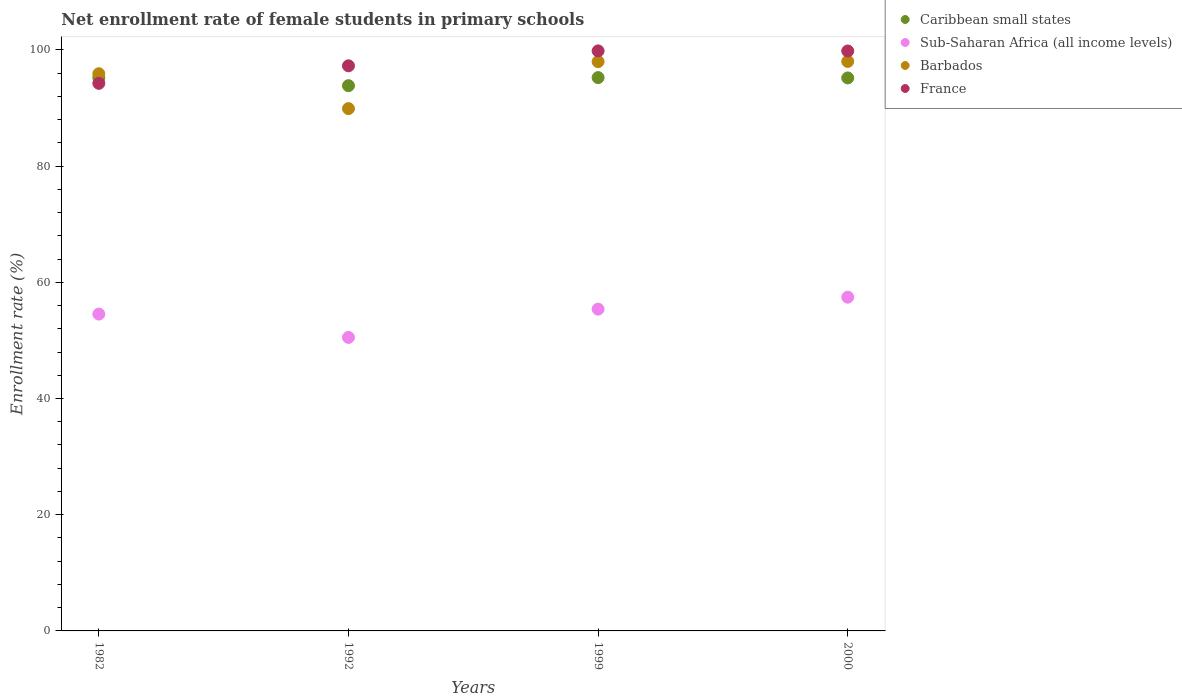How many different coloured dotlines are there?
Offer a terse response. 4. Is the number of dotlines equal to the number of legend labels?
Your answer should be compact. Yes. What is the net enrollment rate of female students in primary schools in Caribbean small states in 1992?
Make the answer very short. 93.84. Across all years, what is the maximum net enrollment rate of female students in primary schools in Sub-Saharan Africa (all income levels)?
Keep it short and to the point. 57.44. Across all years, what is the minimum net enrollment rate of female students in primary schools in Barbados?
Keep it short and to the point. 89.89. What is the total net enrollment rate of female students in primary schools in Sub-Saharan Africa (all income levels) in the graph?
Keep it short and to the point. 217.87. What is the difference between the net enrollment rate of female students in primary schools in Barbados in 1982 and that in 1999?
Offer a very short reply. -2.08. What is the difference between the net enrollment rate of female students in primary schools in Caribbean small states in 2000 and the net enrollment rate of female students in primary schools in Sub-Saharan Africa (all income levels) in 1982?
Provide a short and direct response. 40.64. What is the average net enrollment rate of female students in primary schools in Barbados per year?
Provide a short and direct response. 95.44. In the year 1992, what is the difference between the net enrollment rate of female students in primary schools in France and net enrollment rate of female students in primary schools in Sub-Saharan Africa (all income levels)?
Your answer should be compact. 46.74. In how many years, is the net enrollment rate of female students in primary schools in Caribbean small states greater than 96 %?
Give a very brief answer. 0. What is the ratio of the net enrollment rate of female students in primary schools in Sub-Saharan Africa (all income levels) in 1982 to that in 2000?
Your answer should be compact. 0.95. Is the net enrollment rate of female students in primary schools in Sub-Saharan Africa (all income levels) in 1999 less than that in 2000?
Ensure brevity in your answer.  Yes. What is the difference between the highest and the second highest net enrollment rate of female students in primary schools in Caribbean small states?
Offer a very short reply. 0. What is the difference between the highest and the lowest net enrollment rate of female students in primary schools in Barbados?
Your response must be concise. 8.12. In how many years, is the net enrollment rate of female students in primary schools in France greater than the average net enrollment rate of female students in primary schools in France taken over all years?
Your answer should be very brief. 2. Is the sum of the net enrollment rate of female students in primary schools in Barbados in 1992 and 1999 greater than the maximum net enrollment rate of female students in primary schools in Sub-Saharan Africa (all income levels) across all years?
Keep it short and to the point. Yes. Is it the case that in every year, the sum of the net enrollment rate of female students in primary schools in Barbados and net enrollment rate of female students in primary schools in France  is greater than the sum of net enrollment rate of female students in primary schools in Caribbean small states and net enrollment rate of female students in primary schools in Sub-Saharan Africa (all income levels)?
Your answer should be very brief. Yes. Is it the case that in every year, the sum of the net enrollment rate of female students in primary schools in Sub-Saharan Africa (all income levels) and net enrollment rate of female students in primary schools in Caribbean small states  is greater than the net enrollment rate of female students in primary schools in France?
Provide a short and direct response. Yes. Is the net enrollment rate of female students in primary schools in Caribbean small states strictly less than the net enrollment rate of female students in primary schools in Barbados over the years?
Provide a succinct answer. No. What is the difference between two consecutive major ticks on the Y-axis?
Provide a succinct answer. 20. Does the graph contain grids?
Your answer should be compact. No. How are the legend labels stacked?
Offer a terse response. Vertical. What is the title of the graph?
Give a very brief answer. Net enrollment rate of female students in primary schools. What is the label or title of the Y-axis?
Keep it short and to the point. Enrollment rate (%). What is the Enrollment rate (%) of Caribbean small states in 1982?
Your answer should be very brief. 95.23. What is the Enrollment rate (%) in Sub-Saharan Africa (all income levels) in 1982?
Your answer should be compact. 54.53. What is the Enrollment rate (%) of Barbados in 1982?
Make the answer very short. 95.89. What is the Enrollment rate (%) in France in 1982?
Ensure brevity in your answer.  94.24. What is the Enrollment rate (%) in Caribbean small states in 1992?
Ensure brevity in your answer.  93.84. What is the Enrollment rate (%) of Sub-Saharan Africa (all income levels) in 1992?
Provide a succinct answer. 50.52. What is the Enrollment rate (%) in Barbados in 1992?
Ensure brevity in your answer.  89.89. What is the Enrollment rate (%) in France in 1992?
Provide a short and direct response. 97.26. What is the Enrollment rate (%) of Caribbean small states in 1999?
Offer a very short reply. 95.23. What is the Enrollment rate (%) of Sub-Saharan Africa (all income levels) in 1999?
Your response must be concise. 55.38. What is the Enrollment rate (%) in Barbados in 1999?
Keep it short and to the point. 97.98. What is the Enrollment rate (%) in France in 1999?
Your answer should be very brief. 99.82. What is the Enrollment rate (%) of Caribbean small states in 2000?
Provide a succinct answer. 95.17. What is the Enrollment rate (%) of Sub-Saharan Africa (all income levels) in 2000?
Give a very brief answer. 57.44. What is the Enrollment rate (%) in Barbados in 2000?
Your answer should be very brief. 98.01. What is the Enrollment rate (%) of France in 2000?
Provide a succinct answer. 99.81. Across all years, what is the maximum Enrollment rate (%) in Caribbean small states?
Keep it short and to the point. 95.23. Across all years, what is the maximum Enrollment rate (%) in Sub-Saharan Africa (all income levels)?
Your answer should be compact. 57.44. Across all years, what is the maximum Enrollment rate (%) of Barbados?
Ensure brevity in your answer.  98.01. Across all years, what is the maximum Enrollment rate (%) of France?
Offer a terse response. 99.82. Across all years, what is the minimum Enrollment rate (%) in Caribbean small states?
Provide a short and direct response. 93.84. Across all years, what is the minimum Enrollment rate (%) in Sub-Saharan Africa (all income levels)?
Keep it short and to the point. 50.52. Across all years, what is the minimum Enrollment rate (%) in Barbados?
Make the answer very short. 89.89. Across all years, what is the minimum Enrollment rate (%) of France?
Make the answer very short. 94.24. What is the total Enrollment rate (%) in Caribbean small states in the graph?
Offer a terse response. 379.46. What is the total Enrollment rate (%) in Sub-Saharan Africa (all income levels) in the graph?
Provide a short and direct response. 217.87. What is the total Enrollment rate (%) of Barbados in the graph?
Your answer should be compact. 381.77. What is the total Enrollment rate (%) in France in the graph?
Offer a very short reply. 391.12. What is the difference between the Enrollment rate (%) in Caribbean small states in 1982 and that in 1992?
Your answer should be very brief. 1.39. What is the difference between the Enrollment rate (%) of Sub-Saharan Africa (all income levels) in 1982 and that in 1992?
Ensure brevity in your answer.  4.01. What is the difference between the Enrollment rate (%) in Barbados in 1982 and that in 1992?
Your response must be concise. 6. What is the difference between the Enrollment rate (%) in France in 1982 and that in 1992?
Your answer should be very brief. -3.02. What is the difference between the Enrollment rate (%) of Caribbean small states in 1982 and that in 1999?
Provide a succinct answer. -0. What is the difference between the Enrollment rate (%) in Sub-Saharan Africa (all income levels) in 1982 and that in 1999?
Give a very brief answer. -0.85. What is the difference between the Enrollment rate (%) in Barbados in 1982 and that in 1999?
Ensure brevity in your answer.  -2.08. What is the difference between the Enrollment rate (%) in France in 1982 and that in 1999?
Your answer should be compact. -5.58. What is the difference between the Enrollment rate (%) of Caribbean small states in 1982 and that in 2000?
Offer a very short reply. 0.05. What is the difference between the Enrollment rate (%) of Sub-Saharan Africa (all income levels) in 1982 and that in 2000?
Your response must be concise. -2.91. What is the difference between the Enrollment rate (%) of Barbados in 1982 and that in 2000?
Your answer should be compact. -2.12. What is the difference between the Enrollment rate (%) in France in 1982 and that in 2000?
Offer a very short reply. -5.57. What is the difference between the Enrollment rate (%) in Caribbean small states in 1992 and that in 1999?
Provide a short and direct response. -1.39. What is the difference between the Enrollment rate (%) in Sub-Saharan Africa (all income levels) in 1992 and that in 1999?
Make the answer very short. -4.86. What is the difference between the Enrollment rate (%) of Barbados in 1992 and that in 1999?
Provide a succinct answer. -8.09. What is the difference between the Enrollment rate (%) of France in 1992 and that in 1999?
Offer a very short reply. -2.57. What is the difference between the Enrollment rate (%) in Caribbean small states in 1992 and that in 2000?
Offer a very short reply. -1.34. What is the difference between the Enrollment rate (%) of Sub-Saharan Africa (all income levels) in 1992 and that in 2000?
Your response must be concise. -6.92. What is the difference between the Enrollment rate (%) of Barbados in 1992 and that in 2000?
Your answer should be very brief. -8.12. What is the difference between the Enrollment rate (%) of France in 1992 and that in 2000?
Your response must be concise. -2.55. What is the difference between the Enrollment rate (%) in Caribbean small states in 1999 and that in 2000?
Make the answer very short. 0.06. What is the difference between the Enrollment rate (%) of Sub-Saharan Africa (all income levels) in 1999 and that in 2000?
Your answer should be very brief. -2.06. What is the difference between the Enrollment rate (%) in Barbados in 1999 and that in 2000?
Your response must be concise. -0.03. What is the difference between the Enrollment rate (%) in France in 1999 and that in 2000?
Provide a succinct answer. 0.02. What is the difference between the Enrollment rate (%) in Caribbean small states in 1982 and the Enrollment rate (%) in Sub-Saharan Africa (all income levels) in 1992?
Give a very brief answer. 44.71. What is the difference between the Enrollment rate (%) in Caribbean small states in 1982 and the Enrollment rate (%) in Barbados in 1992?
Provide a succinct answer. 5.34. What is the difference between the Enrollment rate (%) in Caribbean small states in 1982 and the Enrollment rate (%) in France in 1992?
Keep it short and to the point. -2.03. What is the difference between the Enrollment rate (%) in Sub-Saharan Africa (all income levels) in 1982 and the Enrollment rate (%) in Barbados in 1992?
Offer a very short reply. -35.36. What is the difference between the Enrollment rate (%) in Sub-Saharan Africa (all income levels) in 1982 and the Enrollment rate (%) in France in 1992?
Ensure brevity in your answer.  -42.73. What is the difference between the Enrollment rate (%) of Barbados in 1982 and the Enrollment rate (%) of France in 1992?
Your answer should be compact. -1.36. What is the difference between the Enrollment rate (%) in Caribbean small states in 1982 and the Enrollment rate (%) in Sub-Saharan Africa (all income levels) in 1999?
Your answer should be compact. 39.85. What is the difference between the Enrollment rate (%) in Caribbean small states in 1982 and the Enrollment rate (%) in Barbados in 1999?
Give a very brief answer. -2.75. What is the difference between the Enrollment rate (%) in Caribbean small states in 1982 and the Enrollment rate (%) in France in 1999?
Give a very brief answer. -4.6. What is the difference between the Enrollment rate (%) in Sub-Saharan Africa (all income levels) in 1982 and the Enrollment rate (%) in Barbados in 1999?
Give a very brief answer. -43.45. What is the difference between the Enrollment rate (%) in Sub-Saharan Africa (all income levels) in 1982 and the Enrollment rate (%) in France in 1999?
Offer a terse response. -45.29. What is the difference between the Enrollment rate (%) of Barbados in 1982 and the Enrollment rate (%) of France in 1999?
Your response must be concise. -3.93. What is the difference between the Enrollment rate (%) in Caribbean small states in 1982 and the Enrollment rate (%) in Sub-Saharan Africa (all income levels) in 2000?
Provide a short and direct response. 37.79. What is the difference between the Enrollment rate (%) in Caribbean small states in 1982 and the Enrollment rate (%) in Barbados in 2000?
Give a very brief answer. -2.78. What is the difference between the Enrollment rate (%) in Caribbean small states in 1982 and the Enrollment rate (%) in France in 2000?
Your answer should be compact. -4.58. What is the difference between the Enrollment rate (%) of Sub-Saharan Africa (all income levels) in 1982 and the Enrollment rate (%) of Barbados in 2000?
Provide a short and direct response. -43.48. What is the difference between the Enrollment rate (%) in Sub-Saharan Africa (all income levels) in 1982 and the Enrollment rate (%) in France in 2000?
Ensure brevity in your answer.  -45.28. What is the difference between the Enrollment rate (%) of Barbados in 1982 and the Enrollment rate (%) of France in 2000?
Your answer should be very brief. -3.91. What is the difference between the Enrollment rate (%) of Caribbean small states in 1992 and the Enrollment rate (%) of Sub-Saharan Africa (all income levels) in 1999?
Provide a short and direct response. 38.46. What is the difference between the Enrollment rate (%) of Caribbean small states in 1992 and the Enrollment rate (%) of Barbados in 1999?
Ensure brevity in your answer.  -4.14. What is the difference between the Enrollment rate (%) in Caribbean small states in 1992 and the Enrollment rate (%) in France in 1999?
Ensure brevity in your answer.  -5.99. What is the difference between the Enrollment rate (%) of Sub-Saharan Africa (all income levels) in 1992 and the Enrollment rate (%) of Barbados in 1999?
Provide a succinct answer. -47.46. What is the difference between the Enrollment rate (%) of Sub-Saharan Africa (all income levels) in 1992 and the Enrollment rate (%) of France in 1999?
Your answer should be very brief. -49.31. What is the difference between the Enrollment rate (%) in Barbados in 1992 and the Enrollment rate (%) in France in 1999?
Keep it short and to the point. -9.93. What is the difference between the Enrollment rate (%) of Caribbean small states in 1992 and the Enrollment rate (%) of Sub-Saharan Africa (all income levels) in 2000?
Your answer should be very brief. 36.4. What is the difference between the Enrollment rate (%) in Caribbean small states in 1992 and the Enrollment rate (%) in Barbados in 2000?
Ensure brevity in your answer.  -4.17. What is the difference between the Enrollment rate (%) in Caribbean small states in 1992 and the Enrollment rate (%) in France in 2000?
Your answer should be very brief. -5.97. What is the difference between the Enrollment rate (%) in Sub-Saharan Africa (all income levels) in 1992 and the Enrollment rate (%) in Barbados in 2000?
Offer a terse response. -47.49. What is the difference between the Enrollment rate (%) in Sub-Saharan Africa (all income levels) in 1992 and the Enrollment rate (%) in France in 2000?
Make the answer very short. -49.29. What is the difference between the Enrollment rate (%) of Barbados in 1992 and the Enrollment rate (%) of France in 2000?
Give a very brief answer. -9.92. What is the difference between the Enrollment rate (%) in Caribbean small states in 1999 and the Enrollment rate (%) in Sub-Saharan Africa (all income levels) in 2000?
Provide a short and direct response. 37.79. What is the difference between the Enrollment rate (%) in Caribbean small states in 1999 and the Enrollment rate (%) in Barbados in 2000?
Offer a terse response. -2.78. What is the difference between the Enrollment rate (%) of Caribbean small states in 1999 and the Enrollment rate (%) of France in 2000?
Offer a very short reply. -4.58. What is the difference between the Enrollment rate (%) in Sub-Saharan Africa (all income levels) in 1999 and the Enrollment rate (%) in Barbados in 2000?
Offer a very short reply. -42.63. What is the difference between the Enrollment rate (%) of Sub-Saharan Africa (all income levels) in 1999 and the Enrollment rate (%) of France in 2000?
Provide a succinct answer. -44.43. What is the difference between the Enrollment rate (%) of Barbados in 1999 and the Enrollment rate (%) of France in 2000?
Give a very brief answer. -1.83. What is the average Enrollment rate (%) in Caribbean small states per year?
Your answer should be compact. 94.87. What is the average Enrollment rate (%) of Sub-Saharan Africa (all income levels) per year?
Keep it short and to the point. 54.47. What is the average Enrollment rate (%) in Barbados per year?
Offer a terse response. 95.44. What is the average Enrollment rate (%) in France per year?
Your answer should be very brief. 97.78. In the year 1982, what is the difference between the Enrollment rate (%) of Caribbean small states and Enrollment rate (%) of Sub-Saharan Africa (all income levels)?
Keep it short and to the point. 40.7. In the year 1982, what is the difference between the Enrollment rate (%) in Caribbean small states and Enrollment rate (%) in Barbados?
Keep it short and to the point. -0.67. In the year 1982, what is the difference between the Enrollment rate (%) in Caribbean small states and Enrollment rate (%) in France?
Your response must be concise. 0.99. In the year 1982, what is the difference between the Enrollment rate (%) of Sub-Saharan Africa (all income levels) and Enrollment rate (%) of Barbados?
Offer a very short reply. -41.36. In the year 1982, what is the difference between the Enrollment rate (%) of Sub-Saharan Africa (all income levels) and Enrollment rate (%) of France?
Your answer should be very brief. -39.71. In the year 1982, what is the difference between the Enrollment rate (%) in Barbados and Enrollment rate (%) in France?
Give a very brief answer. 1.66. In the year 1992, what is the difference between the Enrollment rate (%) in Caribbean small states and Enrollment rate (%) in Sub-Saharan Africa (all income levels)?
Give a very brief answer. 43.32. In the year 1992, what is the difference between the Enrollment rate (%) of Caribbean small states and Enrollment rate (%) of Barbados?
Your answer should be compact. 3.95. In the year 1992, what is the difference between the Enrollment rate (%) of Caribbean small states and Enrollment rate (%) of France?
Your answer should be compact. -3.42. In the year 1992, what is the difference between the Enrollment rate (%) in Sub-Saharan Africa (all income levels) and Enrollment rate (%) in Barbados?
Your answer should be compact. -39.37. In the year 1992, what is the difference between the Enrollment rate (%) of Sub-Saharan Africa (all income levels) and Enrollment rate (%) of France?
Provide a short and direct response. -46.74. In the year 1992, what is the difference between the Enrollment rate (%) of Barbados and Enrollment rate (%) of France?
Your response must be concise. -7.37. In the year 1999, what is the difference between the Enrollment rate (%) in Caribbean small states and Enrollment rate (%) in Sub-Saharan Africa (all income levels)?
Your response must be concise. 39.85. In the year 1999, what is the difference between the Enrollment rate (%) of Caribbean small states and Enrollment rate (%) of Barbados?
Ensure brevity in your answer.  -2.75. In the year 1999, what is the difference between the Enrollment rate (%) in Caribbean small states and Enrollment rate (%) in France?
Your response must be concise. -4.59. In the year 1999, what is the difference between the Enrollment rate (%) of Sub-Saharan Africa (all income levels) and Enrollment rate (%) of Barbados?
Provide a short and direct response. -42.6. In the year 1999, what is the difference between the Enrollment rate (%) in Sub-Saharan Africa (all income levels) and Enrollment rate (%) in France?
Give a very brief answer. -44.44. In the year 1999, what is the difference between the Enrollment rate (%) of Barbados and Enrollment rate (%) of France?
Keep it short and to the point. -1.84. In the year 2000, what is the difference between the Enrollment rate (%) of Caribbean small states and Enrollment rate (%) of Sub-Saharan Africa (all income levels)?
Make the answer very short. 37.73. In the year 2000, what is the difference between the Enrollment rate (%) in Caribbean small states and Enrollment rate (%) in Barbados?
Provide a succinct answer. -2.84. In the year 2000, what is the difference between the Enrollment rate (%) of Caribbean small states and Enrollment rate (%) of France?
Keep it short and to the point. -4.64. In the year 2000, what is the difference between the Enrollment rate (%) of Sub-Saharan Africa (all income levels) and Enrollment rate (%) of Barbados?
Offer a terse response. -40.57. In the year 2000, what is the difference between the Enrollment rate (%) in Sub-Saharan Africa (all income levels) and Enrollment rate (%) in France?
Give a very brief answer. -42.37. In the year 2000, what is the difference between the Enrollment rate (%) in Barbados and Enrollment rate (%) in France?
Keep it short and to the point. -1.8. What is the ratio of the Enrollment rate (%) of Caribbean small states in 1982 to that in 1992?
Ensure brevity in your answer.  1.01. What is the ratio of the Enrollment rate (%) of Sub-Saharan Africa (all income levels) in 1982 to that in 1992?
Ensure brevity in your answer.  1.08. What is the ratio of the Enrollment rate (%) in Barbados in 1982 to that in 1992?
Ensure brevity in your answer.  1.07. What is the ratio of the Enrollment rate (%) of Sub-Saharan Africa (all income levels) in 1982 to that in 1999?
Ensure brevity in your answer.  0.98. What is the ratio of the Enrollment rate (%) in Barbados in 1982 to that in 1999?
Provide a short and direct response. 0.98. What is the ratio of the Enrollment rate (%) of France in 1982 to that in 1999?
Provide a short and direct response. 0.94. What is the ratio of the Enrollment rate (%) of Sub-Saharan Africa (all income levels) in 1982 to that in 2000?
Ensure brevity in your answer.  0.95. What is the ratio of the Enrollment rate (%) in Barbados in 1982 to that in 2000?
Give a very brief answer. 0.98. What is the ratio of the Enrollment rate (%) of France in 1982 to that in 2000?
Give a very brief answer. 0.94. What is the ratio of the Enrollment rate (%) of Caribbean small states in 1992 to that in 1999?
Your answer should be very brief. 0.99. What is the ratio of the Enrollment rate (%) in Sub-Saharan Africa (all income levels) in 1992 to that in 1999?
Your response must be concise. 0.91. What is the ratio of the Enrollment rate (%) in Barbados in 1992 to that in 1999?
Ensure brevity in your answer.  0.92. What is the ratio of the Enrollment rate (%) of France in 1992 to that in 1999?
Your response must be concise. 0.97. What is the ratio of the Enrollment rate (%) in Sub-Saharan Africa (all income levels) in 1992 to that in 2000?
Give a very brief answer. 0.88. What is the ratio of the Enrollment rate (%) of Barbados in 1992 to that in 2000?
Provide a short and direct response. 0.92. What is the ratio of the Enrollment rate (%) of France in 1992 to that in 2000?
Offer a very short reply. 0.97. What is the ratio of the Enrollment rate (%) of Caribbean small states in 1999 to that in 2000?
Ensure brevity in your answer.  1. What is the ratio of the Enrollment rate (%) of Sub-Saharan Africa (all income levels) in 1999 to that in 2000?
Ensure brevity in your answer.  0.96. What is the ratio of the Enrollment rate (%) of Barbados in 1999 to that in 2000?
Give a very brief answer. 1. What is the ratio of the Enrollment rate (%) in France in 1999 to that in 2000?
Your response must be concise. 1. What is the difference between the highest and the second highest Enrollment rate (%) of Caribbean small states?
Offer a very short reply. 0. What is the difference between the highest and the second highest Enrollment rate (%) of Sub-Saharan Africa (all income levels)?
Your response must be concise. 2.06. What is the difference between the highest and the second highest Enrollment rate (%) of Barbados?
Offer a terse response. 0.03. What is the difference between the highest and the second highest Enrollment rate (%) of France?
Provide a succinct answer. 0.02. What is the difference between the highest and the lowest Enrollment rate (%) of Caribbean small states?
Ensure brevity in your answer.  1.39. What is the difference between the highest and the lowest Enrollment rate (%) of Sub-Saharan Africa (all income levels)?
Give a very brief answer. 6.92. What is the difference between the highest and the lowest Enrollment rate (%) of Barbados?
Your response must be concise. 8.12. What is the difference between the highest and the lowest Enrollment rate (%) of France?
Provide a short and direct response. 5.58. 